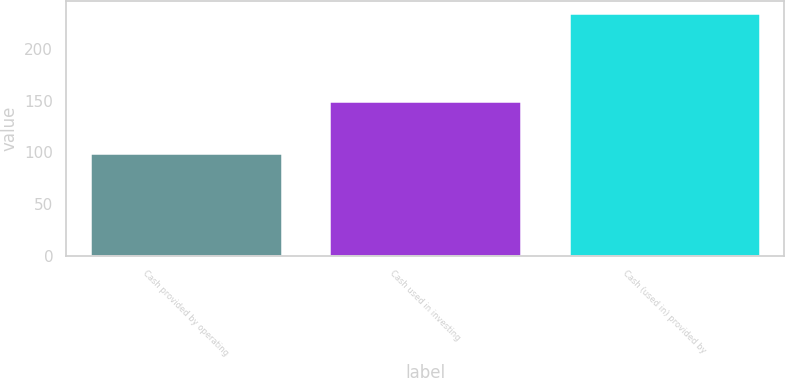<chart> <loc_0><loc_0><loc_500><loc_500><bar_chart><fcel>Cash provided by operating<fcel>Cash used in investing<fcel>Cash (used in) provided by<nl><fcel>99.3<fcel>149.9<fcel>234.5<nl></chart> 